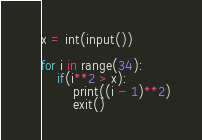<code> <loc_0><loc_0><loc_500><loc_500><_Python_>x = int(input())

for i in range(34):
    if(i**2 > x):
        print((i - 1)**2)
        exit()
</code> 